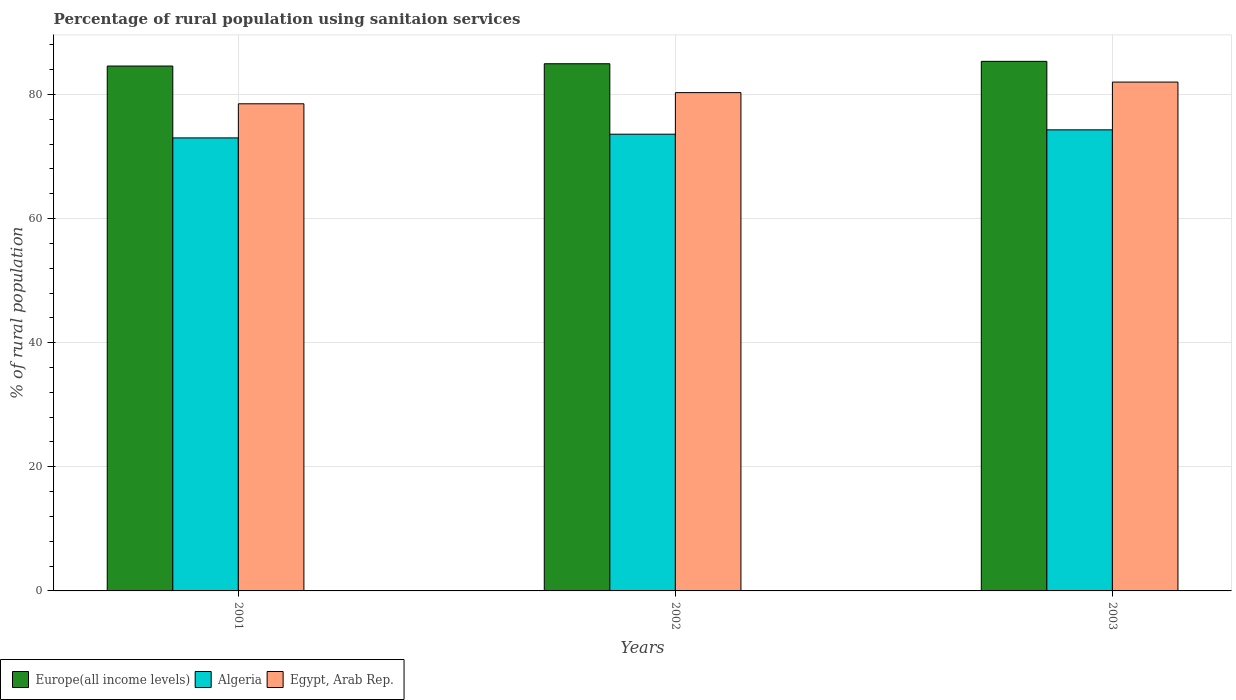How many groups of bars are there?
Keep it short and to the point. 3. Are the number of bars on each tick of the X-axis equal?
Ensure brevity in your answer.  Yes. How many bars are there on the 1st tick from the left?
Offer a terse response. 3. How many bars are there on the 3rd tick from the right?
Give a very brief answer. 3. What is the label of the 3rd group of bars from the left?
Your answer should be very brief. 2003. In how many cases, is the number of bars for a given year not equal to the number of legend labels?
Give a very brief answer. 0. Across all years, what is the maximum percentage of rural population using sanitaion services in Egypt, Arab Rep.?
Provide a short and direct response. 82. Across all years, what is the minimum percentage of rural population using sanitaion services in Europe(all income levels)?
Your answer should be compact. 84.58. In which year was the percentage of rural population using sanitaion services in Europe(all income levels) maximum?
Your answer should be very brief. 2003. In which year was the percentage of rural population using sanitaion services in Europe(all income levels) minimum?
Make the answer very short. 2001. What is the total percentage of rural population using sanitaion services in Algeria in the graph?
Your answer should be compact. 220.9. What is the difference between the percentage of rural population using sanitaion services in Algeria in 2001 and that in 2003?
Make the answer very short. -1.3. What is the difference between the percentage of rural population using sanitaion services in Algeria in 2003 and the percentage of rural population using sanitaion services in Egypt, Arab Rep. in 2002?
Offer a terse response. -6. What is the average percentage of rural population using sanitaion services in Egypt, Arab Rep. per year?
Give a very brief answer. 80.27. In the year 2002, what is the difference between the percentage of rural population using sanitaion services in Algeria and percentage of rural population using sanitaion services in Egypt, Arab Rep.?
Give a very brief answer. -6.7. In how many years, is the percentage of rural population using sanitaion services in Algeria greater than 80 %?
Provide a short and direct response. 0. What is the ratio of the percentage of rural population using sanitaion services in Europe(all income levels) in 2001 to that in 2002?
Keep it short and to the point. 1. Is the percentage of rural population using sanitaion services in Algeria in 2001 less than that in 2002?
Give a very brief answer. Yes. Is the difference between the percentage of rural population using sanitaion services in Algeria in 2001 and 2002 greater than the difference between the percentage of rural population using sanitaion services in Egypt, Arab Rep. in 2001 and 2002?
Your answer should be very brief. Yes. What is the difference between the highest and the second highest percentage of rural population using sanitaion services in Europe(all income levels)?
Ensure brevity in your answer.  0.39. What is the difference between the highest and the lowest percentage of rural population using sanitaion services in Algeria?
Give a very brief answer. 1.3. In how many years, is the percentage of rural population using sanitaion services in Algeria greater than the average percentage of rural population using sanitaion services in Algeria taken over all years?
Offer a terse response. 1. What does the 3rd bar from the left in 2001 represents?
Your response must be concise. Egypt, Arab Rep. What does the 1st bar from the right in 2002 represents?
Provide a succinct answer. Egypt, Arab Rep. Is it the case that in every year, the sum of the percentage of rural population using sanitaion services in Egypt, Arab Rep. and percentage of rural population using sanitaion services in Algeria is greater than the percentage of rural population using sanitaion services in Europe(all income levels)?
Your answer should be very brief. Yes. Are all the bars in the graph horizontal?
Provide a short and direct response. No. What is the difference between two consecutive major ticks on the Y-axis?
Provide a short and direct response. 20. Are the values on the major ticks of Y-axis written in scientific E-notation?
Ensure brevity in your answer.  No. Does the graph contain grids?
Ensure brevity in your answer.  Yes. Where does the legend appear in the graph?
Offer a terse response. Bottom left. How many legend labels are there?
Offer a very short reply. 3. What is the title of the graph?
Keep it short and to the point. Percentage of rural population using sanitaion services. What is the label or title of the Y-axis?
Your response must be concise. % of rural population. What is the % of rural population of Europe(all income levels) in 2001?
Give a very brief answer. 84.58. What is the % of rural population of Algeria in 2001?
Offer a terse response. 73. What is the % of rural population in Egypt, Arab Rep. in 2001?
Your response must be concise. 78.5. What is the % of rural population of Europe(all income levels) in 2002?
Your answer should be very brief. 84.95. What is the % of rural population of Algeria in 2002?
Ensure brevity in your answer.  73.6. What is the % of rural population in Egypt, Arab Rep. in 2002?
Provide a short and direct response. 80.3. What is the % of rural population of Europe(all income levels) in 2003?
Offer a very short reply. 85.34. What is the % of rural population of Algeria in 2003?
Make the answer very short. 74.3. What is the % of rural population in Egypt, Arab Rep. in 2003?
Your answer should be very brief. 82. Across all years, what is the maximum % of rural population in Europe(all income levels)?
Your answer should be compact. 85.34. Across all years, what is the maximum % of rural population of Algeria?
Provide a succinct answer. 74.3. Across all years, what is the maximum % of rural population of Egypt, Arab Rep.?
Provide a succinct answer. 82. Across all years, what is the minimum % of rural population of Europe(all income levels)?
Your response must be concise. 84.58. Across all years, what is the minimum % of rural population in Egypt, Arab Rep.?
Provide a short and direct response. 78.5. What is the total % of rural population of Europe(all income levels) in the graph?
Offer a very short reply. 254.87. What is the total % of rural population in Algeria in the graph?
Your answer should be very brief. 220.9. What is the total % of rural population in Egypt, Arab Rep. in the graph?
Ensure brevity in your answer.  240.8. What is the difference between the % of rural population of Europe(all income levels) in 2001 and that in 2002?
Your response must be concise. -0.37. What is the difference between the % of rural population of Algeria in 2001 and that in 2002?
Ensure brevity in your answer.  -0.6. What is the difference between the % of rural population in Egypt, Arab Rep. in 2001 and that in 2002?
Offer a very short reply. -1.8. What is the difference between the % of rural population in Europe(all income levels) in 2001 and that in 2003?
Keep it short and to the point. -0.76. What is the difference between the % of rural population in Egypt, Arab Rep. in 2001 and that in 2003?
Offer a terse response. -3.5. What is the difference between the % of rural population in Europe(all income levels) in 2002 and that in 2003?
Give a very brief answer. -0.39. What is the difference between the % of rural population in Algeria in 2002 and that in 2003?
Give a very brief answer. -0.7. What is the difference between the % of rural population of Europe(all income levels) in 2001 and the % of rural population of Algeria in 2002?
Provide a short and direct response. 10.98. What is the difference between the % of rural population of Europe(all income levels) in 2001 and the % of rural population of Egypt, Arab Rep. in 2002?
Make the answer very short. 4.28. What is the difference between the % of rural population of Europe(all income levels) in 2001 and the % of rural population of Algeria in 2003?
Make the answer very short. 10.28. What is the difference between the % of rural population in Europe(all income levels) in 2001 and the % of rural population in Egypt, Arab Rep. in 2003?
Ensure brevity in your answer.  2.58. What is the difference between the % of rural population of Algeria in 2001 and the % of rural population of Egypt, Arab Rep. in 2003?
Your answer should be very brief. -9. What is the difference between the % of rural population of Europe(all income levels) in 2002 and the % of rural population of Algeria in 2003?
Provide a short and direct response. 10.65. What is the difference between the % of rural population of Europe(all income levels) in 2002 and the % of rural population of Egypt, Arab Rep. in 2003?
Your answer should be compact. 2.95. What is the difference between the % of rural population of Algeria in 2002 and the % of rural population of Egypt, Arab Rep. in 2003?
Give a very brief answer. -8.4. What is the average % of rural population of Europe(all income levels) per year?
Your answer should be compact. 84.96. What is the average % of rural population of Algeria per year?
Provide a short and direct response. 73.63. What is the average % of rural population in Egypt, Arab Rep. per year?
Offer a very short reply. 80.27. In the year 2001, what is the difference between the % of rural population of Europe(all income levels) and % of rural population of Algeria?
Offer a very short reply. 11.58. In the year 2001, what is the difference between the % of rural population of Europe(all income levels) and % of rural population of Egypt, Arab Rep.?
Provide a short and direct response. 6.08. In the year 2002, what is the difference between the % of rural population in Europe(all income levels) and % of rural population in Algeria?
Offer a terse response. 11.35. In the year 2002, what is the difference between the % of rural population of Europe(all income levels) and % of rural population of Egypt, Arab Rep.?
Provide a short and direct response. 4.65. In the year 2002, what is the difference between the % of rural population in Algeria and % of rural population in Egypt, Arab Rep.?
Offer a very short reply. -6.7. In the year 2003, what is the difference between the % of rural population in Europe(all income levels) and % of rural population in Algeria?
Make the answer very short. 11.04. In the year 2003, what is the difference between the % of rural population in Europe(all income levels) and % of rural population in Egypt, Arab Rep.?
Your answer should be compact. 3.34. In the year 2003, what is the difference between the % of rural population in Algeria and % of rural population in Egypt, Arab Rep.?
Provide a short and direct response. -7.7. What is the ratio of the % of rural population of Europe(all income levels) in 2001 to that in 2002?
Offer a terse response. 1. What is the ratio of the % of rural population of Algeria in 2001 to that in 2002?
Make the answer very short. 0.99. What is the ratio of the % of rural population of Egypt, Arab Rep. in 2001 to that in 2002?
Make the answer very short. 0.98. What is the ratio of the % of rural population of Europe(all income levels) in 2001 to that in 2003?
Provide a short and direct response. 0.99. What is the ratio of the % of rural population in Algeria in 2001 to that in 2003?
Make the answer very short. 0.98. What is the ratio of the % of rural population of Egypt, Arab Rep. in 2001 to that in 2003?
Your response must be concise. 0.96. What is the ratio of the % of rural population of Algeria in 2002 to that in 2003?
Offer a very short reply. 0.99. What is the ratio of the % of rural population of Egypt, Arab Rep. in 2002 to that in 2003?
Make the answer very short. 0.98. What is the difference between the highest and the second highest % of rural population of Europe(all income levels)?
Ensure brevity in your answer.  0.39. What is the difference between the highest and the second highest % of rural population in Algeria?
Provide a succinct answer. 0.7. What is the difference between the highest and the lowest % of rural population of Europe(all income levels)?
Offer a terse response. 0.76. What is the difference between the highest and the lowest % of rural population of Algeria?
Your answer should be compact. 1.3. What is the difference between the highest and the lowest % of rural population of Egypt, Arab Rep.?
Keep it short and to the point. 3.5. 